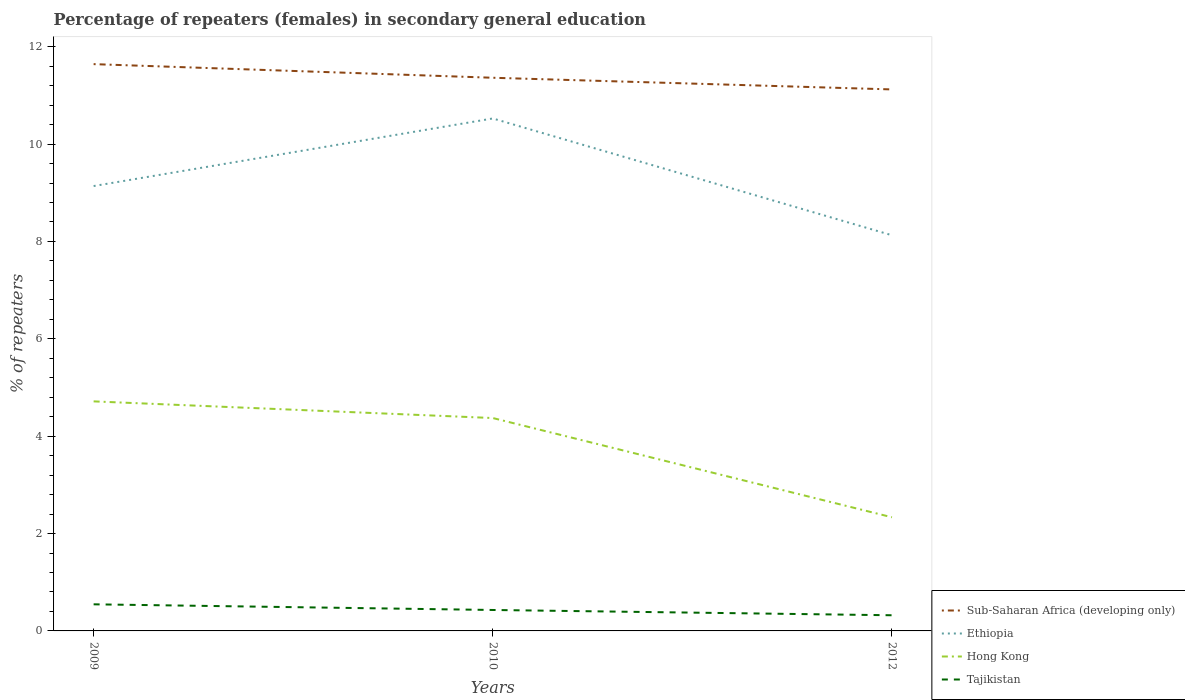Across all years, what is the maximum percentage of female repeaters in Sub-Saharan Africa (developing only)?
Offer a very short reply. 11.12. In which year was the percentage of female repeaters in Sub-Saharan Africa (developing only) maximum?
Your response must be concise. 2012. What is the total percentage of female repeaters in Ethiopia in the graph?
Ensure brevity in your answer.  1.01. What is the difference between the highest and the second highest percentage of female repeaters in Tajikistan?
Offer a very short reply. 0.22. What is the difference between the highest and the lowest percentage of female repeaters in Hong Kong?
Offer a very short reply. 2. How many years are there in the graph?
Offer a terse response. 3. Are the values on the major ticks of Y-axis written in scientific E-notation?
Provide a succinct answer. No. Does the graph contain any zero values?
Provide a short and direct response. No. Does the graph contain grids?
Offer a terse response. No. Where does the legend appear in the graph?
Offer a very short reply. Bottom right. What is the title of the graph?
Your response must be concise. Percentage of repeaters (females) in secondary general education. Does "Austria" appear as one of the legend labels in the graph?
Provide a succinct answer. No. What is the label or title of the X-axis?
Your answer should be compact. Years. What is the label or title of the Y-axis?
Offer a very short reply. % of repeaters. What is the % of repeaters in Sub-Saharan Africa (developing only) in 2009?
Offer a terse response. 11.64. What is the % of repeaters of Ethiopia in 2009?
Provide a succinct answer. 9.14. What is the % of repeaters in Hong Kong in 2009?
Make the answer very short. 4.72. What is the % of repeaters in Tajikistan in 2009?
Keep it short and to the point. 0.55. What is the % of repeaters of Sub-Saharan Africa (developing only) in 2010?
Make the answer very short. 11.36. What is the % of repeaters in Ethiopia in 2010?
Keep it short and to the point. 10.53. What is the % of repeaters in Hong Kong in 2010?
Make the answer very short. 4.37. What is the % of repeaters of Tajikistan in 2010?
Your answer should be compact. 0.43. What is the % of repeaters of Sub-Saharan Africa (developing only) in 2012?
Provide a succinct answer. 11.12. What is the % of repeaters of Ethiopia in 2012?
Your response must be concise. 8.13. What is the % of repeaters in Hong Kong in 2012?
Your response must be concise. 2.33. What is the % of repeaters in Tajikistan in 2012?
Provide a short and direct response. 0.32. Across all years, what is the maximum % of repeaters of Sub-Saharan Africa (developing only)?
Keep it short and to the point. 11.64. Across all years, what is the maximum % of repeaters of Ethiopia?
Your answer should be very brief. 10.53. Across all years, what is the maximum % of repeaters in Hong Kong?
Provide a short and direct response. 4.72. Across all years, what is the maximum % of repeaters in Tajikistan?
Make the answer very short. 0.55. Across all years, what is the minimum % of repeaters in Sub-Saharan Africa (developing only)?
Provide a short and direct response. 11.12. Across all years, what is the minimum % of repeaters of Ethiopia?
Your response must be concise. 8.13. Across all years, what is the minimum % of repeaters in Hong Kong?
Your response must be concise. 2.33. Across all years, what is the minimum % of repeaters of Tajikistan?
Offer a very short reply. 0.32. What is the total % of repeaters in Sub-Saharan Africa (developing only) in the graph?
Provide a short and direct response. 34.13. What is the total % of repeaters in Ethiopia in the graph?
Your answer should be compact. 27.79. What is the total % of repeaters of Hong Kong in the graph?
Make the answer very short. 11.42. What is the total % of repeaters in Tajikistan in the graph?
Offer a terse response. 1.3. What is the difference between the % of repeaters in Sub-Saharan Africa (developing only) in 2009 and that in 2010?
Your response must be concise. 0.28. What is the difference between the % of repeaters of Ethiopia in 2009 and that in 2010?
Offer a terse response. -1.39. What is the difference between the % of repeaters of Hong Kong in 2009 and that in 2010?
Make the answer very short. 0.34. What is the difference between the % of repeaters of Tajikistan in 2009 and that in 2010?
Your answer should be compact. 0.12. What is the difference between the % of repeaters of Sub-Saharan Africa (developing only) in 2009 and that in 2012?
Your answer should be very brief. 0.52. What is the difference between the % of repeaters in Ethiopia in 2009 and that in 2012?
Keep it short and to the point. 1.01. What is the difference between the % of repeaters in Hong Kong in 2009 and that in 2012?
Your answer should be very brief. 2.38. What is the difference between the % of repeaters in Tajikistan in 2009 and that in 2012?
Ensure brevity in your answer.  0.22. What is the difference between the % of repeaters of Sub-Saharan Africa (developing only) in 2010 and that in 2012?
Keep it short and to the point. 0.24. What is the difference between the % of repeaters in Ethiopia in 2010 and that in 2012?
Give a very brief answer. 2.4. What is the difference between the % of repeaters in Hong Kong in 2010 and that in 2012?
Your response must be concise. 2.04. What is the difference between the % of repeaters in Tajikistan in 2010 and that in 2012?
Provide a short and direct response. 0.11. What is the difference between the % of repeaters in Sub-Saharan Africa (developing only) in 2009 and the % of repeaters in Ethiopia in 2010?
Provide a succinct answer. 1.12. What is the difference between the % of repeaters in Sub-Saharan Africa (developing only) in 2009 and the % of repeaters in Hong Kong in 2010?
Make the answer very short. 7.27. What is the difference between the % of repeaters in Sub-Saharan Africa (developing only) in 2009 and the % of repeaters in Tajikistan in 2010?
Your response must be concise. 11.21. What is the difference between the % of repeaters in Ethiopia in 2009 and the % of repeaters in Hong Kong in 2010?
Provide a succinct answer. 4.77. What is the difference between the % of repeaters of Ethiopia in 2009 and the % of repeaters of Tajikistan in 2010?
Your response must be concise. 8.71. What is the difference between the % of repeaters in Hong Kong in 2009 and the % of repeaters in Tajikistan in 2010?
Ensure brevity in your answer.  4.28. What is the difference between the % of repeaters in Sub-Saharan Africa (developing only) in 2009 and the % of repeaters in Ethiopia in 2012?
Your response must be concise. 3.51. What is the difference between the % of repeaters in Sub-Saharan Africa (developing only) in 2009 and the % of repeaters in Hong Kong in 2012?
Offer a terse response. 9.31. What is the difference between the % of repeaters in Sub-Saharan Africa (developing only) in 2009 and the % of repeaters in Tajikistan in 2012?
Your answer should be very brief. 11.32. What is the difference between the % of repeaters in Ethiopia in 2009 and the % of repeaters in Hong Kong in 2012?
Ensure brevity in your answer.  6.8. What is the difference between the % of repeaters of Ethiopia in 2009 and the % of repeaters of Tajikistan in 2012?
Your answer should be compact. 8.82. What is the difference between the % of repeaters in Hong Kong in 2009 and the % of repeaters in Tajikistan in 2012?
Your answer should be compact. 4.39. What is the difference between the % of repeaters in Sub-Saharan Africa (developing only) in 2010 and the % of repeaters in Ethiopia in 2012?
Your answer should be very brief. 3.24. What is the difference between the % of repeaters in Sub-Saharan Africa (developing only) in 2010 and the % of repeaters in Hong Kong in 2012?
Your answer should be compact. 9.03. What is the difference between the % of repeaters in Sub-Saharan Africa (developing only) in 2010 and the % of repeaters in Tajikistan in 2012?
Ensure brevity in your answer.  11.04. What is the difference between the % of repeaters of Ethiopia in 2010 and the % of repeaters of Hong Kong in 2012?
Make the answer very short. 8.19. What is the difference between the % of repeaters of Ethiopia in 2010 and the % of repeaters of Tajikistan in 2012?
Provide a succinct answer. 10.2. What is the difference between the % of repeaters of Hong Kong in 2010 and the % of repeaters of Tajikistan in 2012?
Provide a succinct answer. 4.05. What is the average % of repeaters in Sub-Saharan Africa (developing only) per year?
Ensure brevity in your answer.  11.38. What is the average % of repeaters in Ethiopia per year?
Your response must be concise. 9.26. What is the average % of repeaters in Hong Kong per year?
Give a very brief answer. 3.81. What is the average % of repeaters in Tajikistan per year?
Your answer should be compact. 0.43. In the year 2009, what is the difference between the % of repeaters in Sub-Saharan Africa (developing only) and % of repeaters in Ethiopia?
Give a very brief answer. 2.5. In the year 2009, what is the difference between the % of repeaters in Sub-Saharan Africa (developing only) and % of repeaters in Hong Kong?
Provide a succinct answer. 6.93. In the year 2009, what is the difference between the % of repeaters of Sub-Saharan Africa (developing only) and % of repeaters of Tajikistan?
Give a very brief answer. 11.1. In the year 2009, what is the difference between the % of repeaters of Ethiopia and % of repeaters of Hong Kong?
Provide a succinct answer. 4.42. In the year 2009, what is the difference between the % of repeaters in Ethiopia and % of repeaters in Tajikistan?
Make the answer very short. 8.59. In the year 2009, what is the difference between the % of repeaters in Hong Kong and % of repeaters in Tajikistan?
Your response must be concise. 4.17. In the year 2010, what is the difference between the % of repeaters of Sub-Saharan Africa (developing only) and % of repeaters of Ethiopia?
Offer a terse response. 0.84. In the year 2010, what is the difference between the % of repeaters in Sub-Saharan Africa (developing only) and % of repeaters in Hong Kong?
Your answer should be compact. 6.99. In the year 2010, what is the difference between the % of repeaters in Sub-Saharan Africa (developing only) and % of repeaters in Tajikistan?
Provide a succinct answer. 10.93. In the year 2010, what is the difference between the % of repeaters in Ethiopia and % of repeaters in Hong Kong?
Provide a short and direct response. 6.15. In the year 2010, what is the difference between the % of repeaters of Ethiopia and % of repeaters of Tajikistan?
Provide a succinct answer. 10.1. In the year 2010, what is the difference between the % of repeaters of Hong Kong and % of repeaters of Tajikistan?
Offer a very short reply. 3.94. In the year 2012, what is the difference between the % of repeaters in Sub-Saharan Africa (developing only) and % of repeaters in Ethiopia?
Your answer should be compact. 3. In the year 2012, what is the difference between the % of repeaters of Sub-Saharan Africa (developing only) and % of repeaters of Hong Kong?
Provide a short and direct response. 8.79. In the year 2012, what is the difference between the % of repeaters of Sub-Saharan Africa (developing only) and % of repeaters of Tajikistan?
Ensure brevity in your answer.  10.8. In the year 2012, what is the difference between the % of repeaters in Ethiopia and % of repeaters in Hong Kong?
Your answer should be very brief. 5.79. In the year 2012, what is the difference between the % of repeaters of Ethiopia and % of repeaters of Tajikistan?
Keep it short and to the point. 7.81. In the year 2012, what is the difference between the % of repeaters in Hong Kong and % of repeaters in Tajikistan?
Provide a succinct answer. 2.01. What is the ratio of the % of repeaters of Sub-Saharan Africa (developing only) in 2009 to that in 2010?
Provide a succinct answer. 1.02. What is the ratio of the % of repeaters of Ethiopia in 2009 to that in 2010?
Offer a very short reply. 0.87. What is the ratio of the % of repeaters of Hong Kong in 2009 to that in 2010?
Ensure brevity in your answer.  1.08. What is the ratio of the % of repeaters in Tajikistan in 2009 to that in 2010?
Your answer should be very brief. 1.27. What is the ratio of the % of repeaters of Sub-Saharan Africa (developing only) in 2009 to that in 2012?
Offer a terse response. 1.05. What is the ratio of the % of repeaters of Ethiopia in 2009 to that in 2012?
Offer a terse response. 1.12. What is the ratio of the % of repeaters in Hong Kong in 2009 to that in 2012?
Offer a terse response. 2.02. What is the ratio of the % of repeaters in Tajikistan in 2009 to that in 2012?
Your answer should be very brief. 1.7. What is the ratio of the % of repeaters in Sub-Saharan Africa (developing only) in 2010 to that in 2012?
Ensure brevity in your answer.  1.02. What is the ratio of the % of repeaters in Ethiopia in 2010 to that in 2012?
Make the answer very short. 1.3. What is the ratio of the % of repeaters of Hong Kong in 2010 to that in 2012?
Provide a succinct answer. 1.87. What is the ratio of the % of repeaters of Tajikistan in 2010 to that in 2012?
Keep it short and to the point. 1.34. What is the difference between the highest and the second highest % of repeaters of Sub-Saharan Africa (developing only)?
Provide a short and direct response. 0.28. What is the difference between the highest and the second highest % of repeaters of Ethiopia?
Your response must be concise. 1.39. What is the difference between the highest and the second highest % of repeaters in Hong Kong?
Offer a very short reply. 0.34. What is the difference between the highest and the second highest % of repeaters in Tajikistan?
Your answer should be compact. 0.12. What is the difference between the highest and the lowest % of repeaters of Sub-Saharan Africa (developing only)?
Ensure brevity in your answer.  0.52. What is the difference between the highest and the lowest % of repeaters of Ethiopia?
Ensure brevity in your answer.  2.4. What is the difference between the highest and the lowest % of repeaters in Hong Kong?
Your answer should be very brief. 2.38. What is the difference between the highest and the lowest % of repeaters in Tajikistan?
Provide a short and direct response. 0.22. 